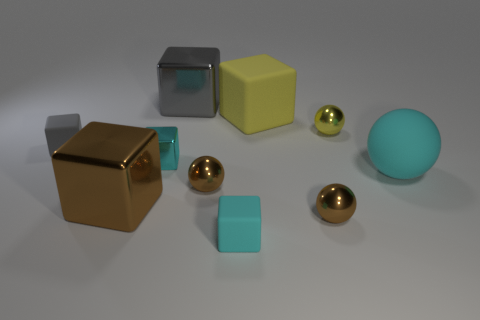What material is the cyan thing that is to the right of the small cyan cube right of the tiny metal block?
Your answer should be very brief. Rubber. What is the size of the gray cube behind the tiny metal sphere that is behind the matte thing that is to the left of the big brown metal cube?
Provide a short and direct response. Large. Does the large gray thing have the same shape as the large metallic object in front of the cyan shiny block?
Provide a short and direct response. Yes. What is the brown block made of?
Offer a very short reply. Metal. What number of rubber objects are big brown blocks or small yellow spheres?
Offer a very short reply. 0. Are there fewer cyan rubber objects that are behind the small yellow metallic thing than large cyan rubber balls that are on the left side of the gray shiny thing?
Make the answer very short. No. There is a big brown metallic object in front of the matte cube on the left side of the small cyan shiny thing; is there a small cyan metallic thing that is on the right side of it?
Your response must be concise. Yes. There is a large object that is the same color as the tiny metal cube; what is it made of?
Provide a short and direct response. Rubber. Do the tiny rubber object left of the cyan shiny object and the cyan object that is behind the large sphere have the same shape?
Offer a terse response. Yes. There is a gray cube that is the same size as the matte ball; what is its material?
Your response must be concise. Metal. 